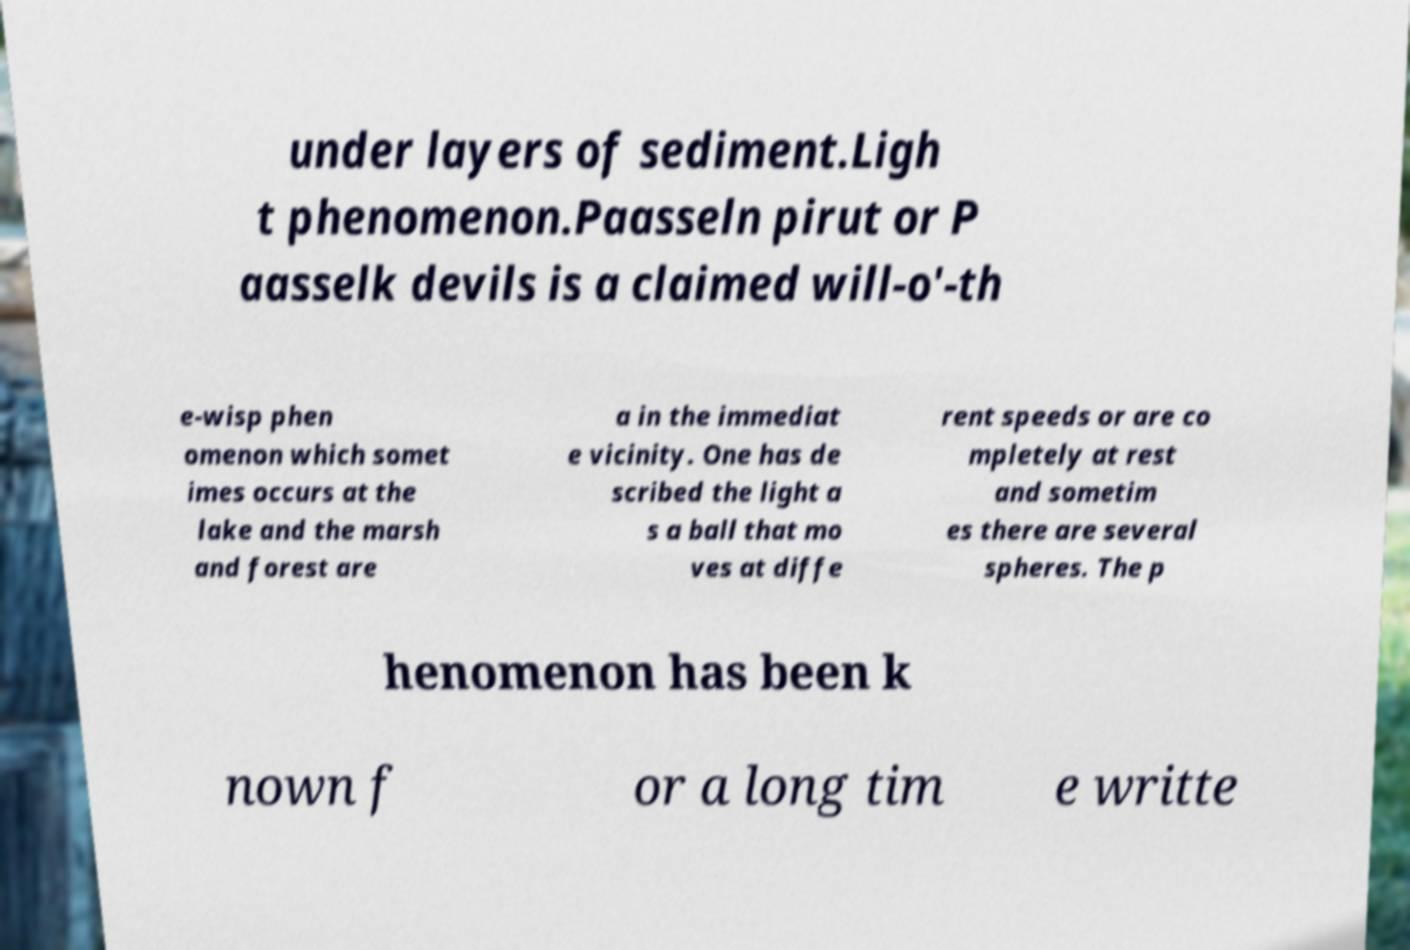Can you read and provide the text displayed in the image?This photo seems to have some interesting text. Can you extract and type it out for me? under layers of sediment.Ligh t phenomenon.Paasseln pirut or P aasselk devils is a claimed will-o'-th e-wisp phen omenon which somet imes occurs at the lake and the marsh and forest are a in the immediat e vicinity. One has de scribed the light a s a ball that mo ves at diffe rent speeds or are co mpletely at rest and sometim es there are several spheres. The p henomenon has been k nown f or a long tim e writte 